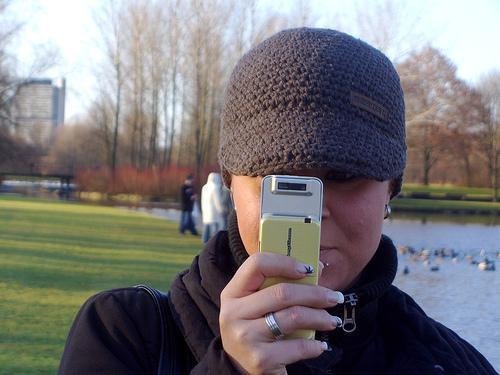How many phones is she holding?
Give a very brief answer. 1. How many people are reading book?
Give a very brief answer. 0. 